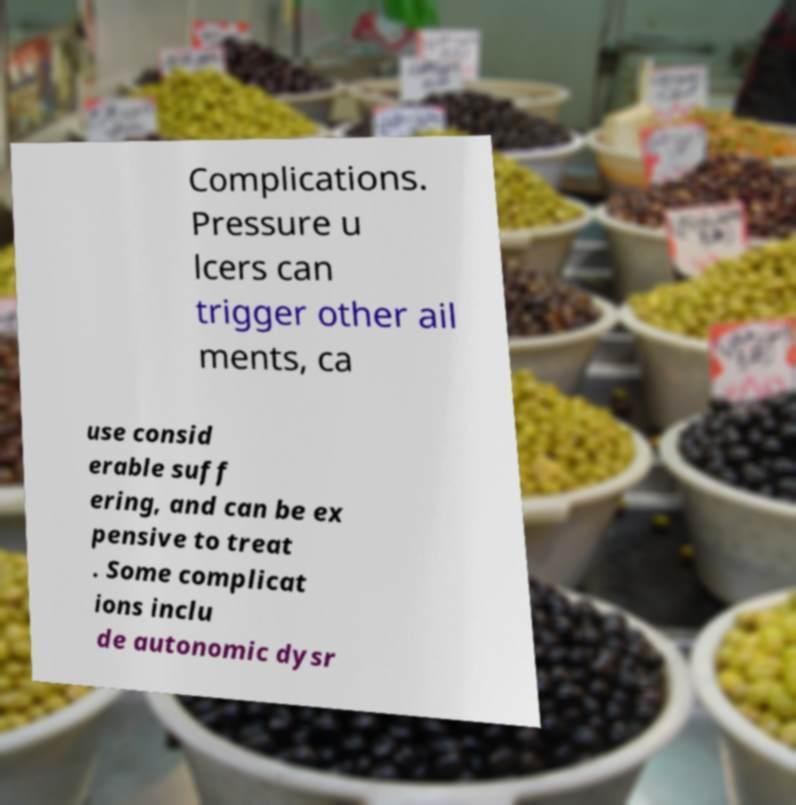Could you extract and type out the text from this image? Complications. Pressure u lcers can trigger other ail ments, ca use consid erable suff ering, and can be ex pensive to treat . Some complicat ions inclu de autonomic dysr 